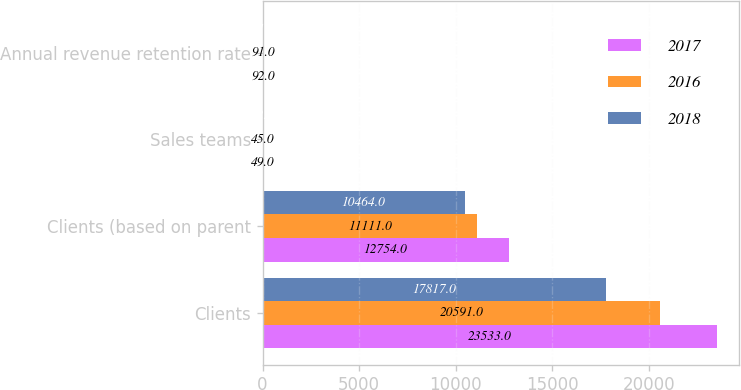Convert chart. <chart><loc_0><loc_0><loc_500><loc_500><stacked_bar_chart><ecel><fcel>Clients<fcel>Clients (based on parent<fcel>Sales teams<fcel>Annual revenue retention rate<nl><fcel>2017<fcel>23533<fcel>12754<fcel>49<fcel>92<nl><fcel>2016<fcel>20591<fcel>11111<fcel>45<fcel>91<nl><fcel>2018<fcel>17817<fcel>10464<fcel>42<fcel>91<nl></chart> 